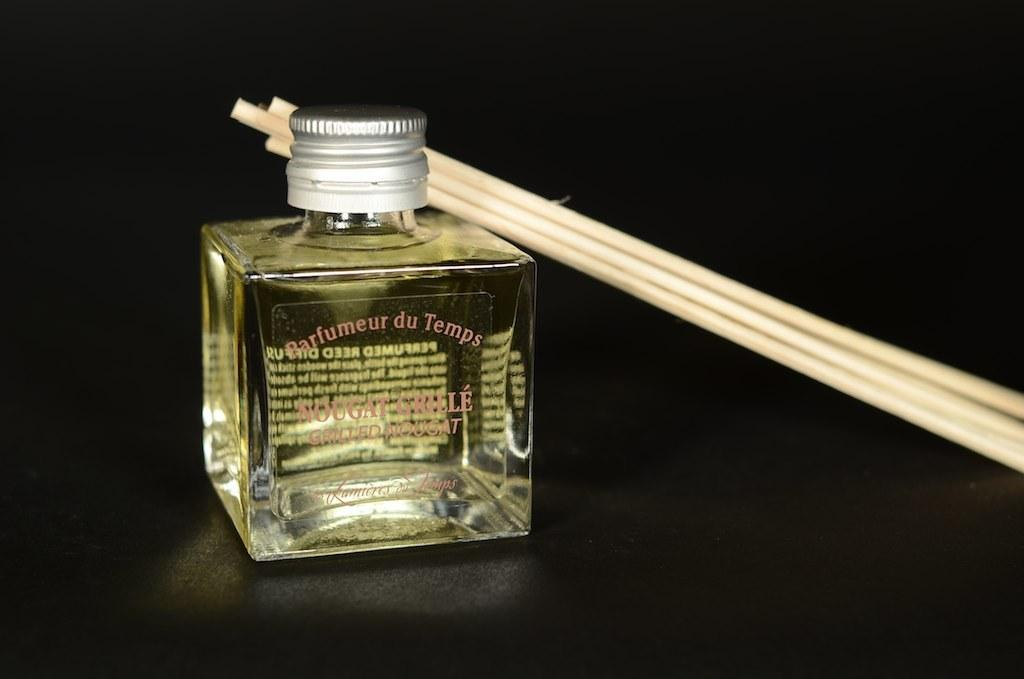<image>
Provide a brief description of the given image. Parfumeur de Temps comes in a small square bottle and is yellowish in color. 